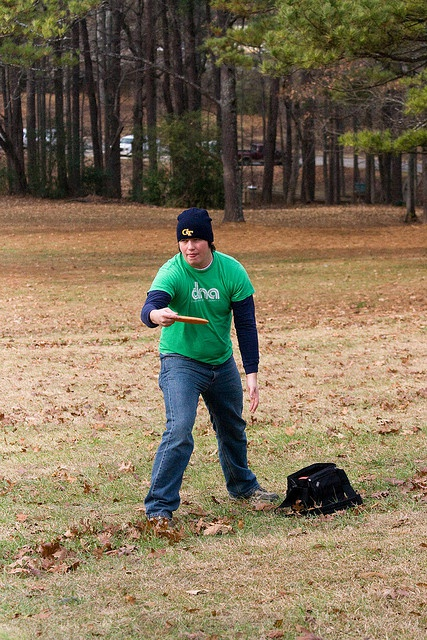Describe the objects in this image and their specific colors. I can see people in olive, black, teal, green, and navy tones, handbag in olive, black, gray, darkgreen, and maroon tones, car in olive, black, gray, and purple tones, car in olive, lavender, darkgray, gray, and black tones, and car in olive, gray, black, and darkgray tones in this image. 